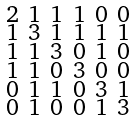<formula> <loc_0><loc_0><loc_500><loc_500>\begin{smallmatrix} 2 & 1 & 1 & 1 & 0 & 0 \\ 1 & 3 & 1 & 1 & 1 & 1 \\ 1 & 1 & 3 & 0 & 1 & 0 \\ 1 & 1 & 0 & 3 & 0 & 0 \\ 0 & 1 & 1 & 0 & 3 & 1 \\ 0 & 1 & 0 & 0 & 1 & 3 \end{smallmatrix}</formula> 